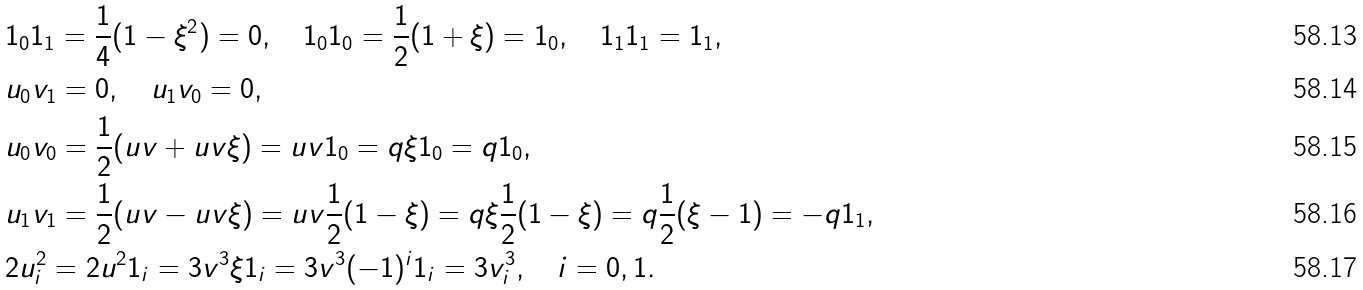Convert formula to latex. <formula><loc_0><loc_0><loc_500><loc_500>& { 1 } _ { 0 } { 1 } _ { 1 } = \frac { 1 } { 4 } ( 1 - \xi ^ { 2 } ) = 0 , \quad 1 _ { 0 } { 1 } _ { 0 } = \frac { 1 } { 2 } ( 1 + \xi ) = { 1 } _ { 0 } , \quad 1 _ { 1 } { 1 } _ { 1 } = { 1 } _ { 1 } , \\ & u _ { 0 } v _ { 1 } = 0 , \quad u _ { 1 } v _ { 0 } = 0 , \\ & u _ { 0 } v _ { 0 } = \frac { 1 } { 2 } ( u v + u v \xi ) = u v { 1 } _ { 0 } = q \xi { 1 } _ { 0 } = q { 1 } _ { 0 } , \\ & u _ { 1 } v _ { 1 } = \frac { 1 } { 2 } ( u v - u v \xi ) = u v \frac { 1 } { 2 } ( 1 - \xi ) = q \xi \frac { 1 } { 2 } ( 1 - \xi ) = q \frac { 1 } { 2 } ( \xi - 1 ) = - q { 1 } _ { 1 } , \\ & 2 u _ { i } ^ { 2 } = 2 u ^ { 2 } { 1 } _ { i } = 3 v ^ { 3 } \xi { 1 } _ { i } = 3 v ^ { 3 } ( - 1 ) ^ { i } { 1 } _ { i } = 3 v _ { i } ^ { 3 } , \quad i = 0 , 1 .</formula> 